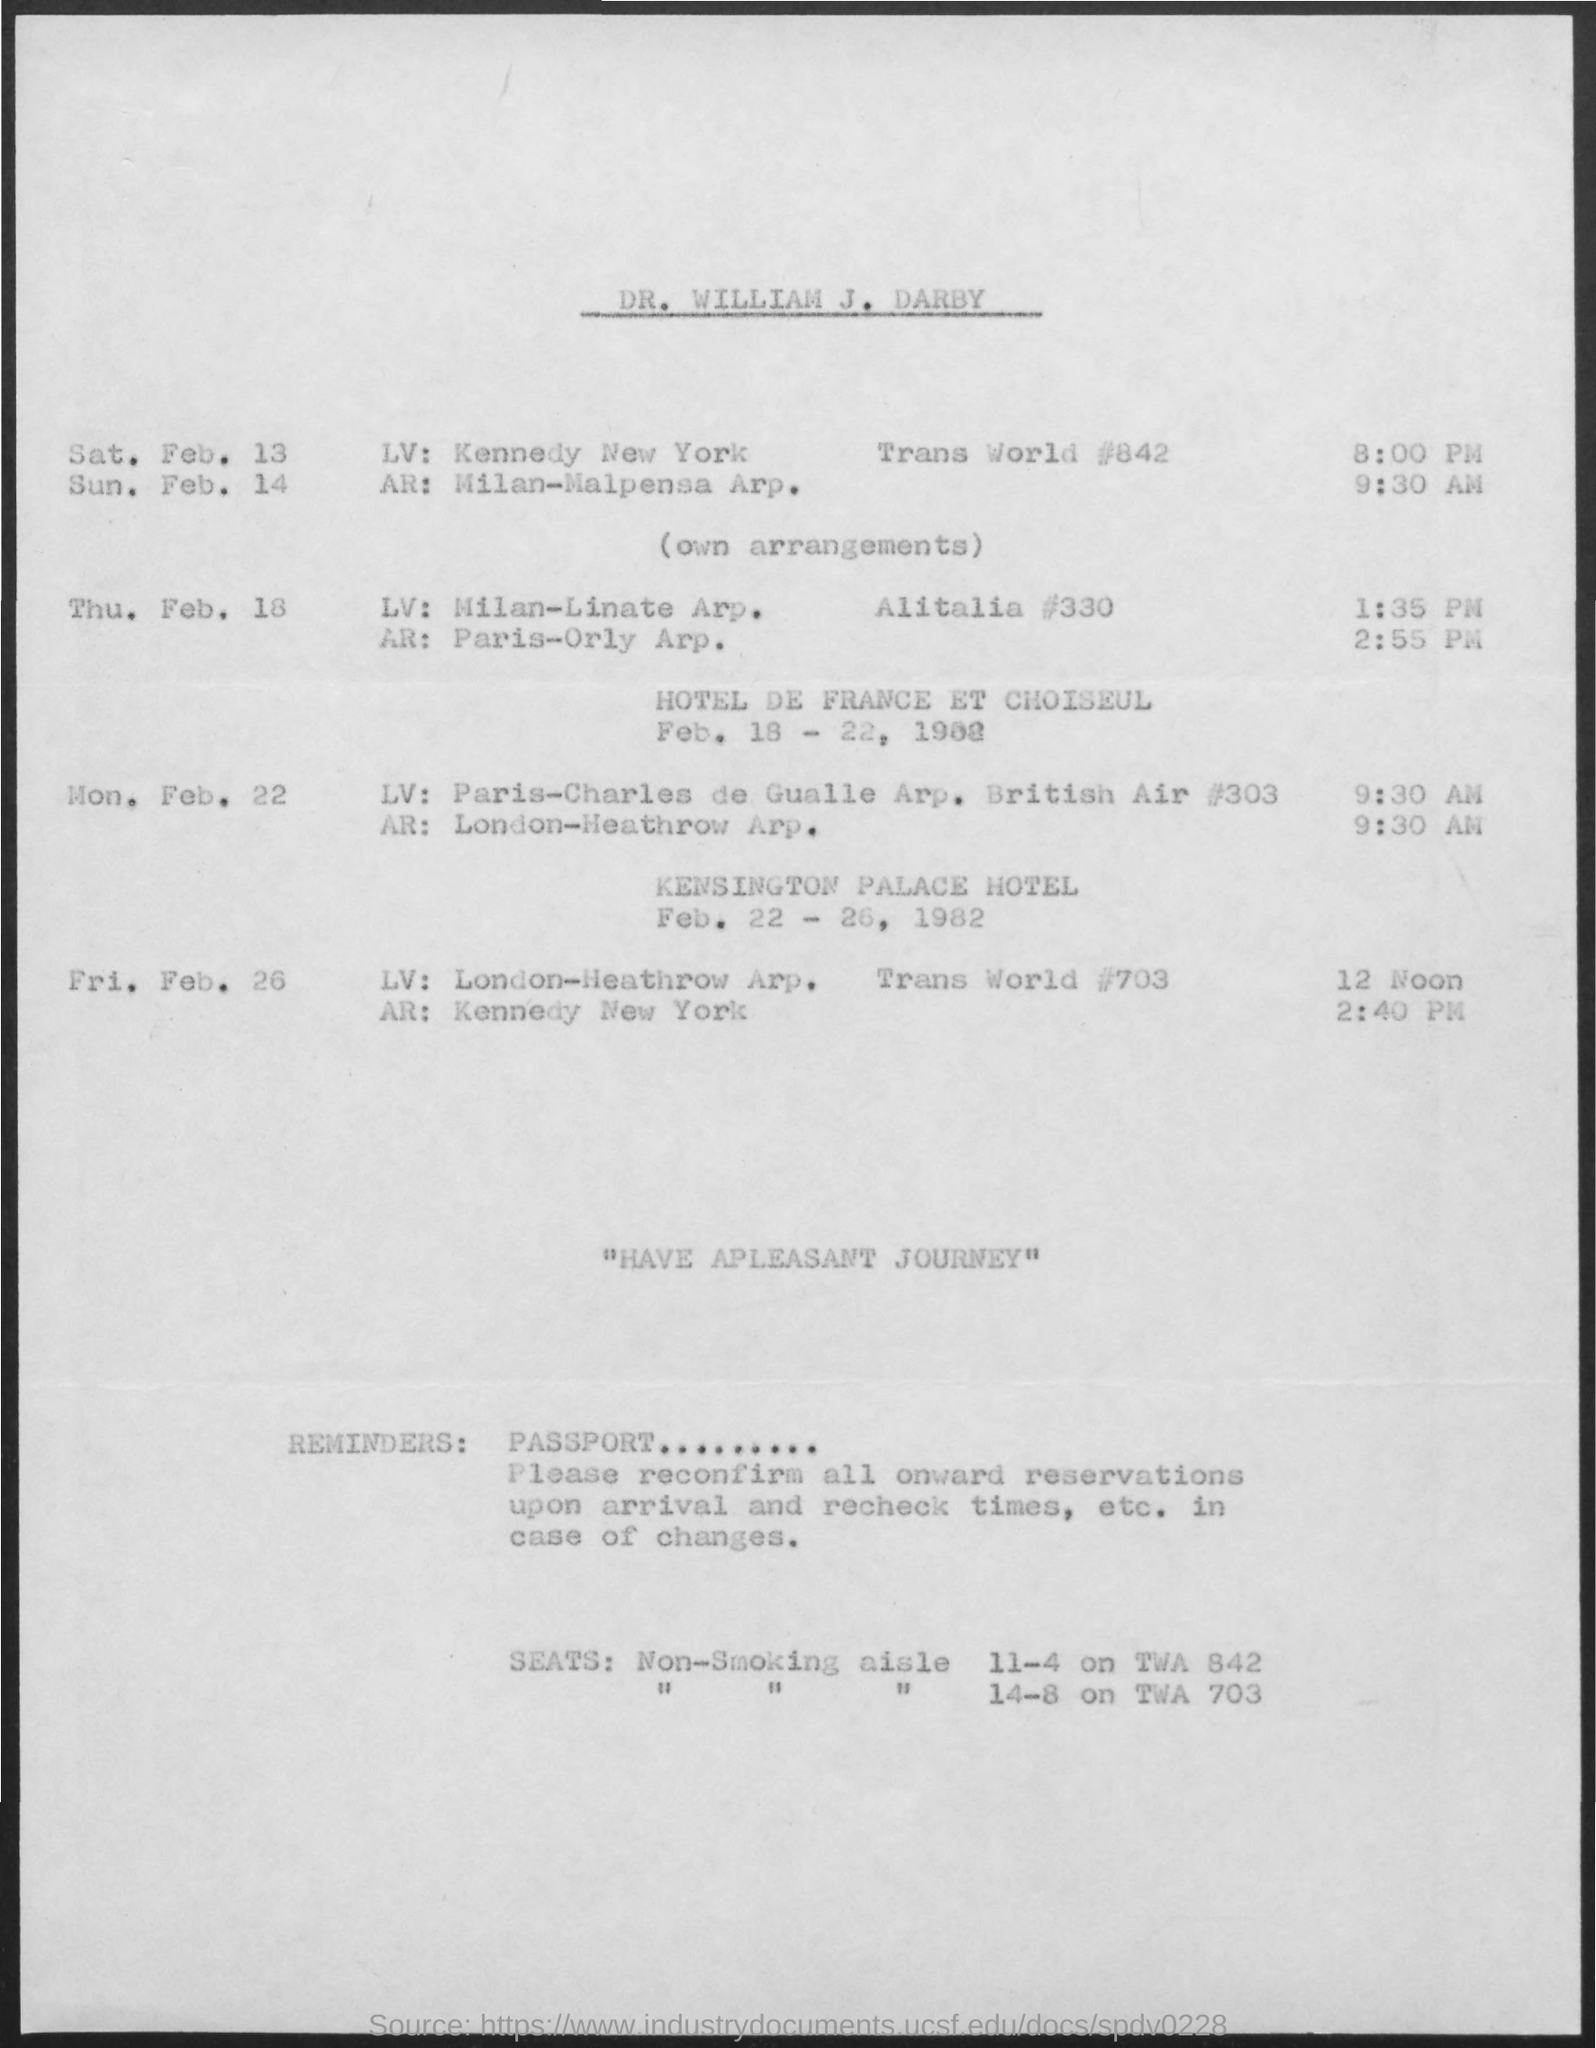What is the title of the document?
Your answer should be very brief. DR. William J. Darby. 